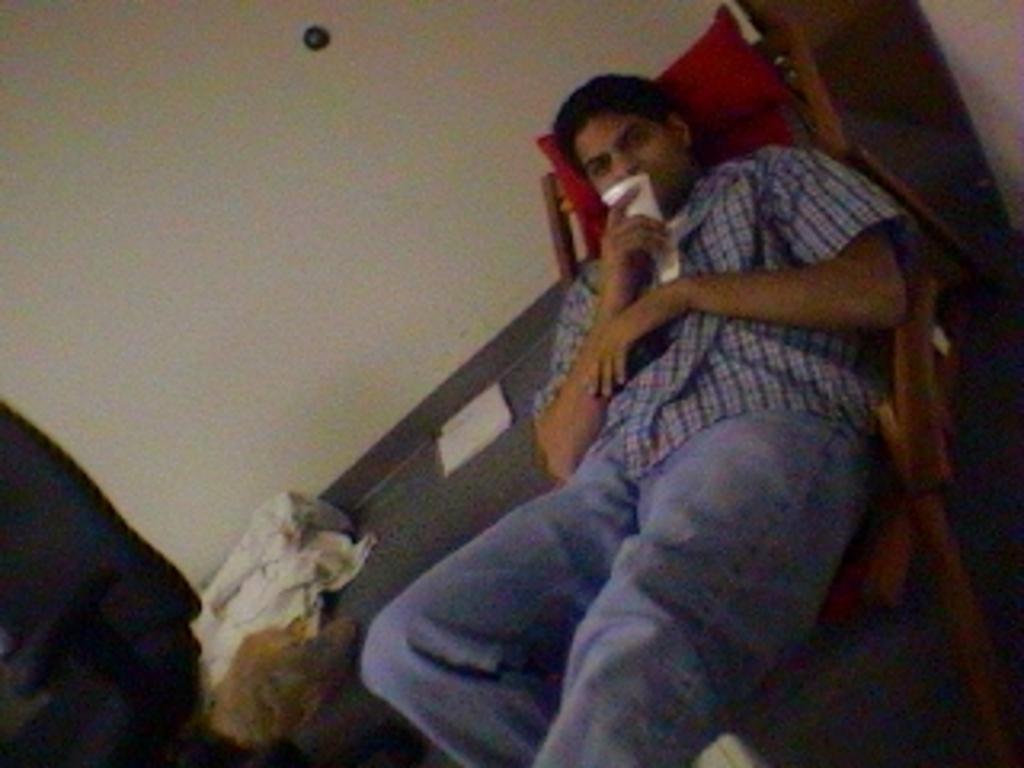Could you give a brief overview of what you see in this image? In this image, we can see a person sitting on a chair and holding a cup with his hand. There is a dog and cloth in the bottom left of the image. There is a wall at the top of the image. 